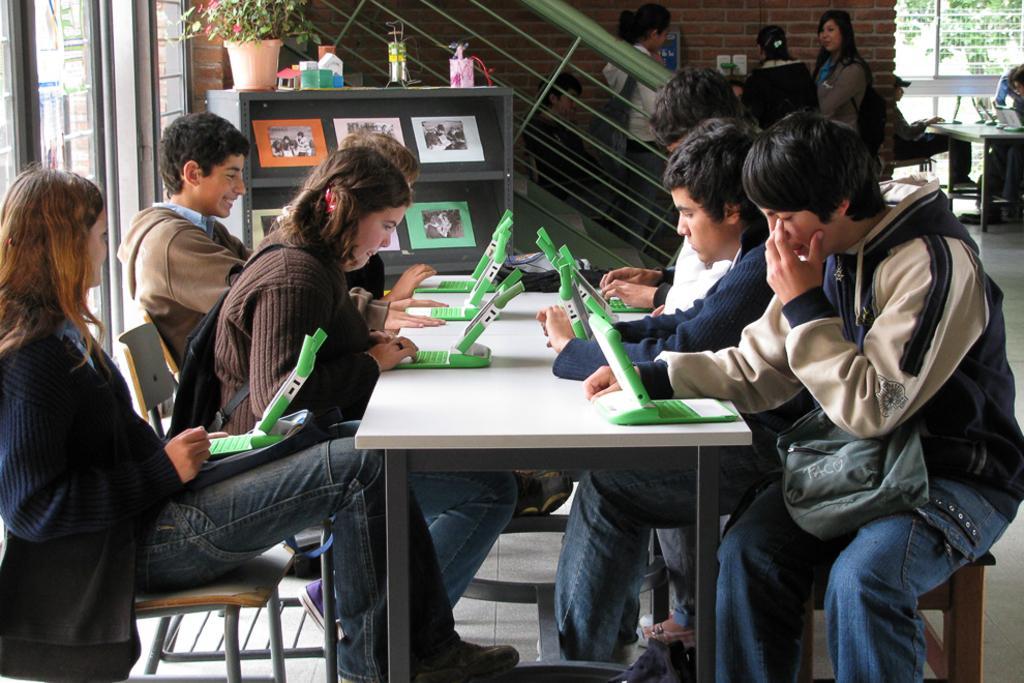How would you summarize this image in a sentence or two? There are few people sitting on the chairs. This is a table with some green color gadgets on it. There are few people standing. These are the posters attached to the rack. I can see a flower pot and some objects on it. This looks like a staircase holder. 